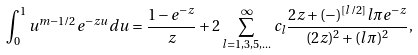Convert formula to latex. <formula><loc_0><loc_0><loc_500><loc_500>\int _ { 0 } ^ { 1 } u ^ { m - 1 / 2 } e ^ { - z u } d u = \frac { 1 - e ^ { - z } } { z } + 2 \sum _ { l = 1 , 3 , 5 , \dots } ^ { \infty } c _ { l } \frac { 2 z + ( - ) ^ { [ l / 2 ] } l \pi e ^ { - z } } { ( 2 z ) ^ { 2 } + ( l \pi ) ^ { 2 } } ,</formula> 